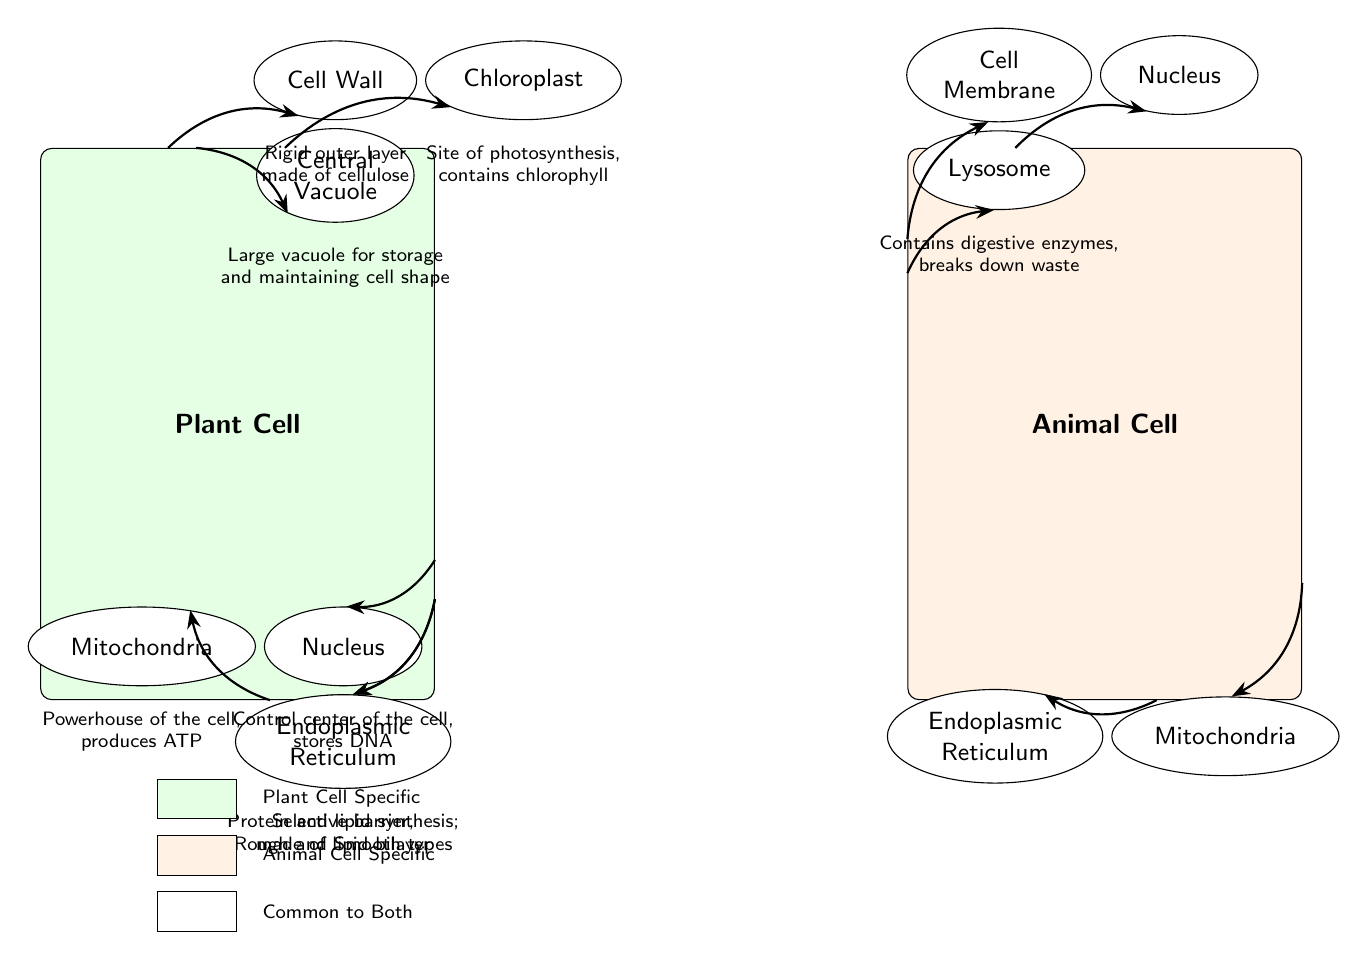What is the outer layer of a plant cell made of? The diagram shows the plant cell has a "Cell Wall" labeled, which is identified as a "Rigid outer layer made of cellulose" in an annotation. This clearly indicates that the outer layer of the plant cell is composed of cellulose.
Answer: Cellulose How many organelles are specific to plant cells? In the diagram, the plant cell is labeled with three specific organelles: "Cell Wall," "Chloroplast," and "Central Vacuole." Thus, we count these to determine that there are three organelles specific to plant cells.
Answer: 3 What organelle is responsible for photosynthesis in plant cells? The diagram identifies "Chloroplast" as an organelle in the plant cell, and it is described in the annotation as "Site of photosynthesis, contains chlorophyll." This confirms that chloroplasts are responsible for photosynthesis.
Answer: Chloroplast Which cell has a central vacuole? The diagram illustrates that only the plant cell includes a "Central Vacuole," stated in its specific annotations, while the animal cell does not include this organelle. Therefore, we can conclude that the plant cell has the central vacuole.
Answer: Plant Cell What structure aids in digestion in animal cells? The diagram indicates that the animal cell contains a "Lysosome," which is explicitly described in the annotation as "Contains digestive enzymes, breaks down waste." This states the role of lysosomes in digestion for animal cells.
Answer: Lysosome Which part of the animal cell is labeled as the control center? The diagram shows a "Nucleus" in the animal cell section, with an annotation that states "Control center of the cell, stores DNA." This provides direct information about its function.
Answer: Nucleus How many types of endoplasmic reticulum are mentioned? The diagram positions "Endoplasmic Reticulum" in both cells, and there is a note that specifies "Rough and Smooth types," signifying that there are two types of endoplasmic reticulum discussed.
Answer: 2 What is common between both plant and animal cells regarding their outer membrane? The diagram shows that both the plant and animal cells have a "Cell Membrane." Annotations state that it serves as a "Selective barrier, made of lipid bilayer" and not exclusive to one type of cell, indicating its commonality.
Answer: Cell Membrane What color represents the plant cell in the diagram? The plant cell is filled with a green shade labeled in the diagram. The specific color for the plant cell is green, which is essential to identification by visual representation.
Answer: Green 